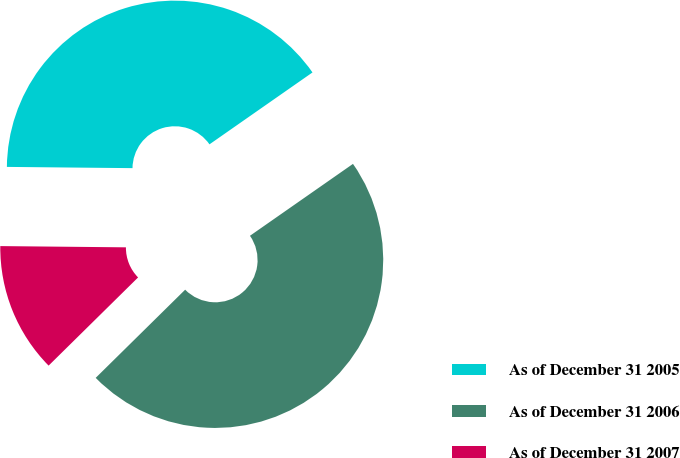<chart> <loc_0><loc_0><loc_500><loc_500><pie_chart><fcel>As of December 31 2005<fcel>As of December 31 2006<fcel>As of December 31 2007<nl><fcel>40.14%<fcel>47.31%<fcel>12.54%<nl></chart> 